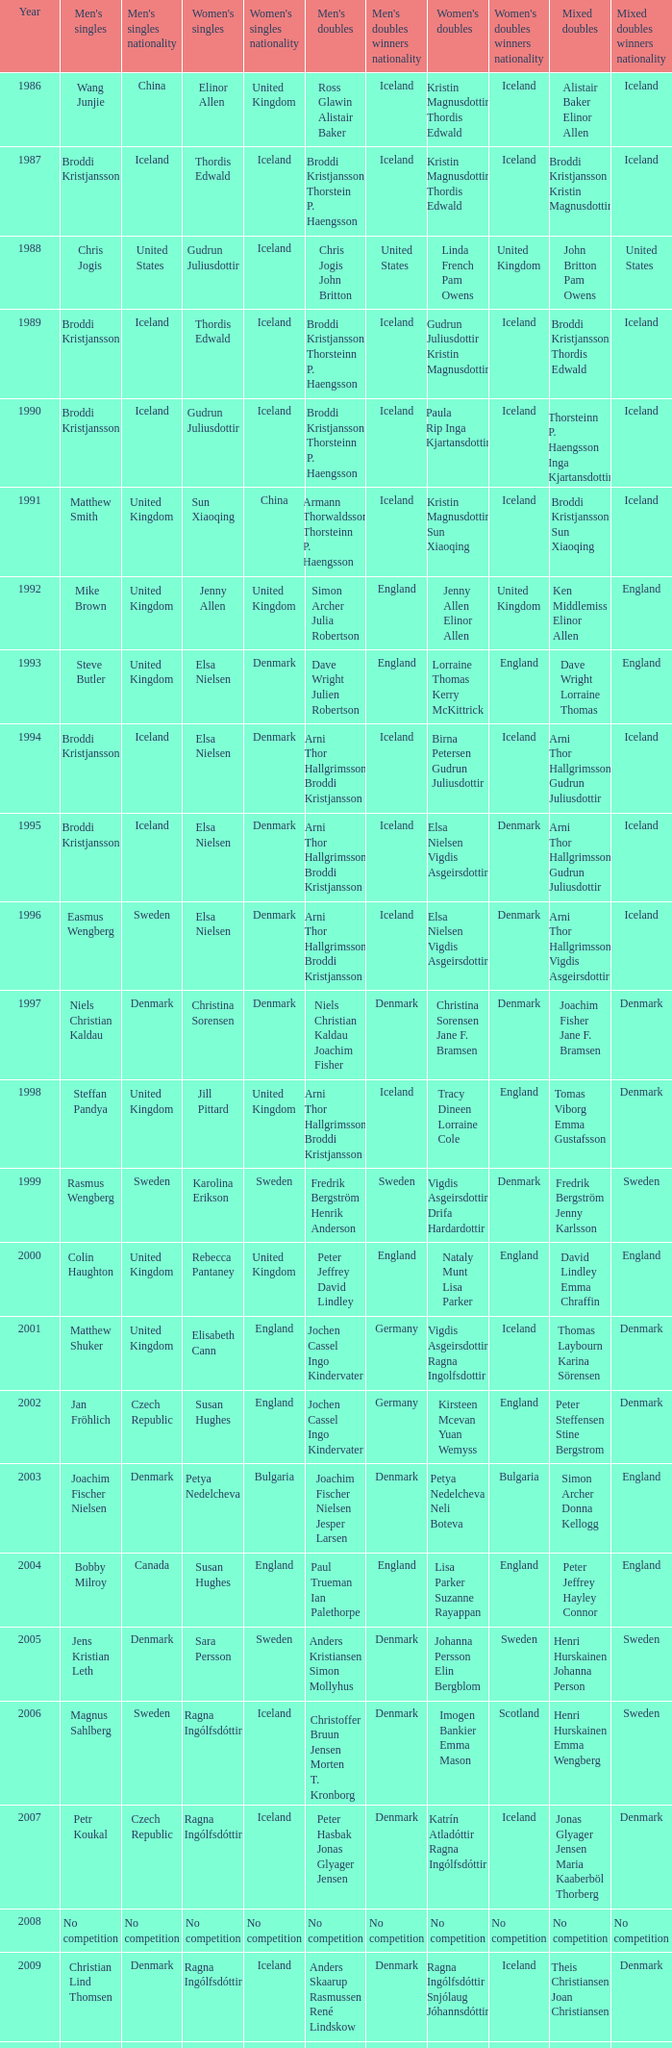Which mixed doubles happened later than 2011? Chou Tien-chen Chiang Mei-hui. 